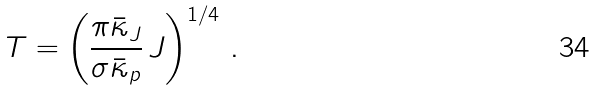<formula> <loc_0><loc_0><loc_500><loc_500>T = \left ( \frac { \pi \bar { \kappa } _ { J } } { \sigma \bar { \kappa } _ { p } } \, J \right ) ^ { 1 / 4 } \, .</formula> 